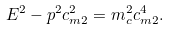<formula> <loc_0><loc_0><loc_500><loc_500>E ^ { 2 } - p ^ { 2 } c _ { m 2 } ^ { 2 } = m _ { c } ^ { 2 } c _ { m 2 } ^ { 4 } .</formula> 